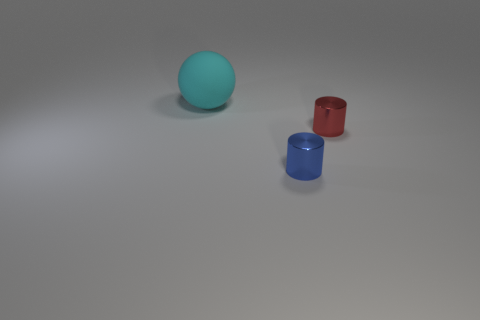How many tiny objects are in front of the red cylinder?
Provide a succinct answer. 1. Is there a cyan cylinder?
Your answer should be compact. No. What size is the object left of the blue thing on the left side of the small cylinder that is behind the blue cylinder?
Offer a very short reply. Large. How many other objects are there of the same size as the matte sphere?
Ensure brevity in your answer.  0. How big is the object left of the blue object?
Offer a very short reply. Large. Does the tiny thing right of the blue object have the same material as the cyan ball?
Ensure brevity in your answer.  No. How many things are both on the left side of the small red cylinder and in front of the cyan matte thing?
Provide a succinct answer. 1. There is a thing left of the metal thing to the left of the red metal thing; how big is it?
Offer a very short reply. Large. Are there any other things that have the same material as the cyan sphere?
Give a very brief answer. No. Is the number of tiny red cylinders greater than the number of green matte cubes?
Offer a very short reply. Yes. 